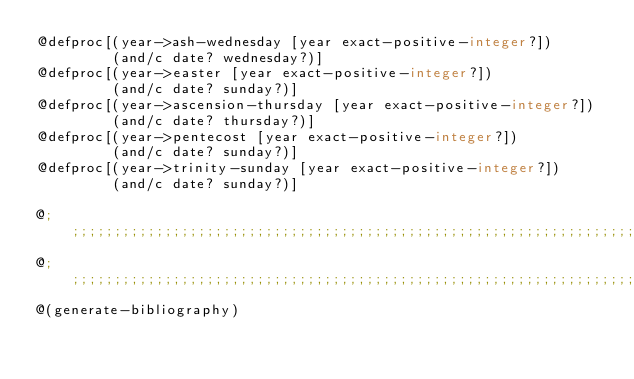<code> <loc_0><loc_0><loc_500><loc_500><_Racket_>@defproc[(year->ash-wednesday [year exact-positive-integer?])
         (and/c date? wednesday?)]
@defproc[(year->easter [year exact-positive-integer?])
         (and/c date? sunday?)]
@defproc[(year->ascension-thursday [year exact-positive-integer?])
         (and/c date? thursday?)]
@defproc[(year->pentecost [year exact-positive-integer?])
         (and/c date? sunday?)]
@defproc[(year->trinity-sunday [year exact-positive-integer?])
         (and/c date? sunday?)]

@;;;;;;;;;;;;;;;;;;;;;;;;;;;;;;;;;;;;;;;;;;;;;;;;;;;;;;;;;;;;;;;;;;;;;;;;;;;;;;
@;;;;;;;;;;;;;;;;;;;;;;;;;;;;;;;;;;;;;;;;;;;;;;;;;;;;;;;;;;;;;;;;;;;;;;;;;;;;;;
@(generate-bibliography)
</code> 